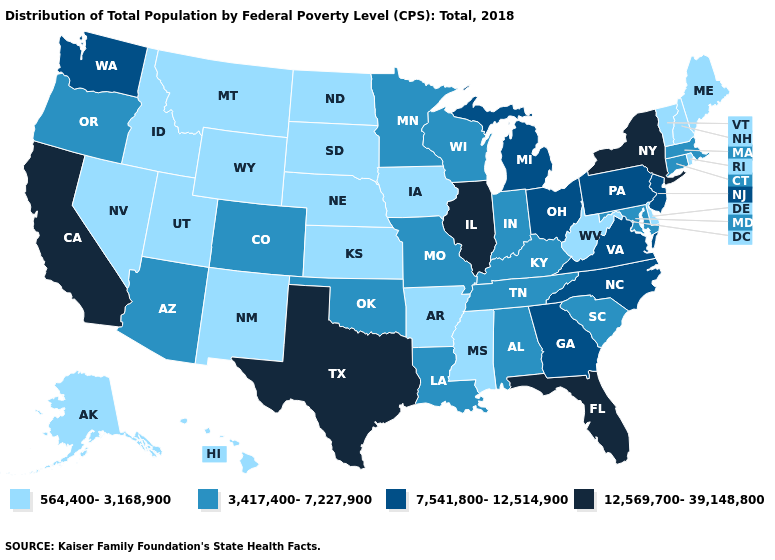Name the states that have a value in the range 7,541,800-12,514,900?
Keep it brief. Georgia, Michigan, New Jersey, North Carolina, Ohio, Pennsylvania, Virginia, Washington. Which states have the highest value in the USA?
Be succinct. California, Florida, Illinois, New York, Texas. How many symbols are there in the legend?
Answer briefly. 4. Name the states that have a value in the range 3,417,400-7,227,900?
Short answer required. Alabama, Arizona, Colorado, Connecticut, Indiana, Kentucky, Louisiana, Maryland, Massachusetts, Minnesota, Missouri, Oklahoma, Oregon, South Carolina, Tennessee, Wisconsin. How many symbols are there in the legend?
Short answer required. 4. Does Iowa have the highest value in the MidWest?
Short answer required. No. Does the map have missing data?
Keep it brief. No. Among the states that border Wisconsin , does Iowa have the lowest value?
Give a very brief answer. Yes. What is the highest value in the Northeast ?
Write a very short answer. 12,569,700-39,148,800. What is the value of West Virginia?
Short answer required. 564,400-3,168,900. Which states have the lowest value in the West?
Keep it brief. Alaska, Hawaii, Idaho, Montana, Nevada, New Mexico, Utah, Wyoming. Does the first symbol in the legend represent the smallest category?
Be succinct. Yes. What is the value of Minnesota?
Answer briefly. 3,417,400-7,227,900. What is the value of Arkansas?
Write a very short answer. 564,400-3,168,900. Does New Hampshire have the lowest value in the USA?
Write a very short answer. Yes. 